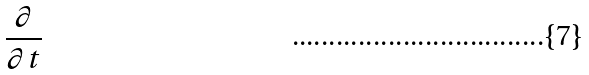Convert formula to latex. <formula><loc_0><loc_0><loc_500><loc_500>\frac { \partial } { \partial t }</formula> 